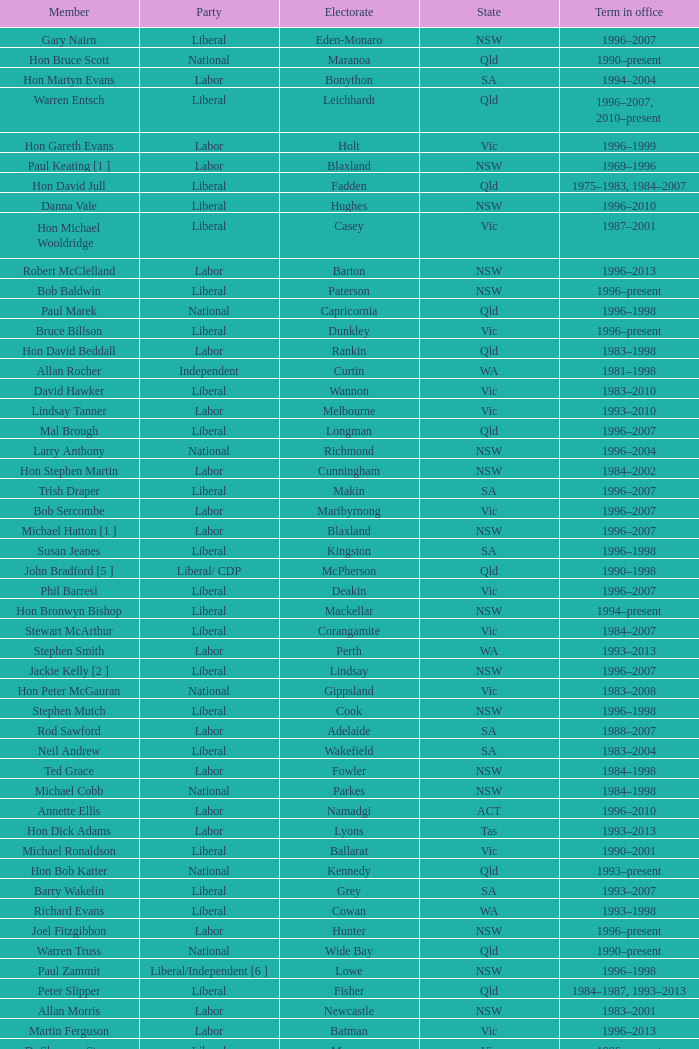What state did Hon David Beddall belong to? Qld. 